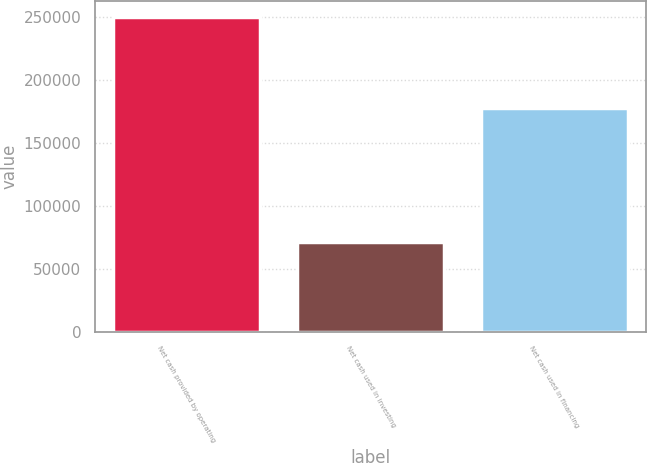Convert chart. <chart><loc_0><loc_0><loc_500><loc_500><bar_chart><fcel>Net cash provided by operating<fcel>Net cash used in investing<fcel>Net cash used in financing<nl><fcel>250578<fcel>71397<fcel>178105<nl></chart> 